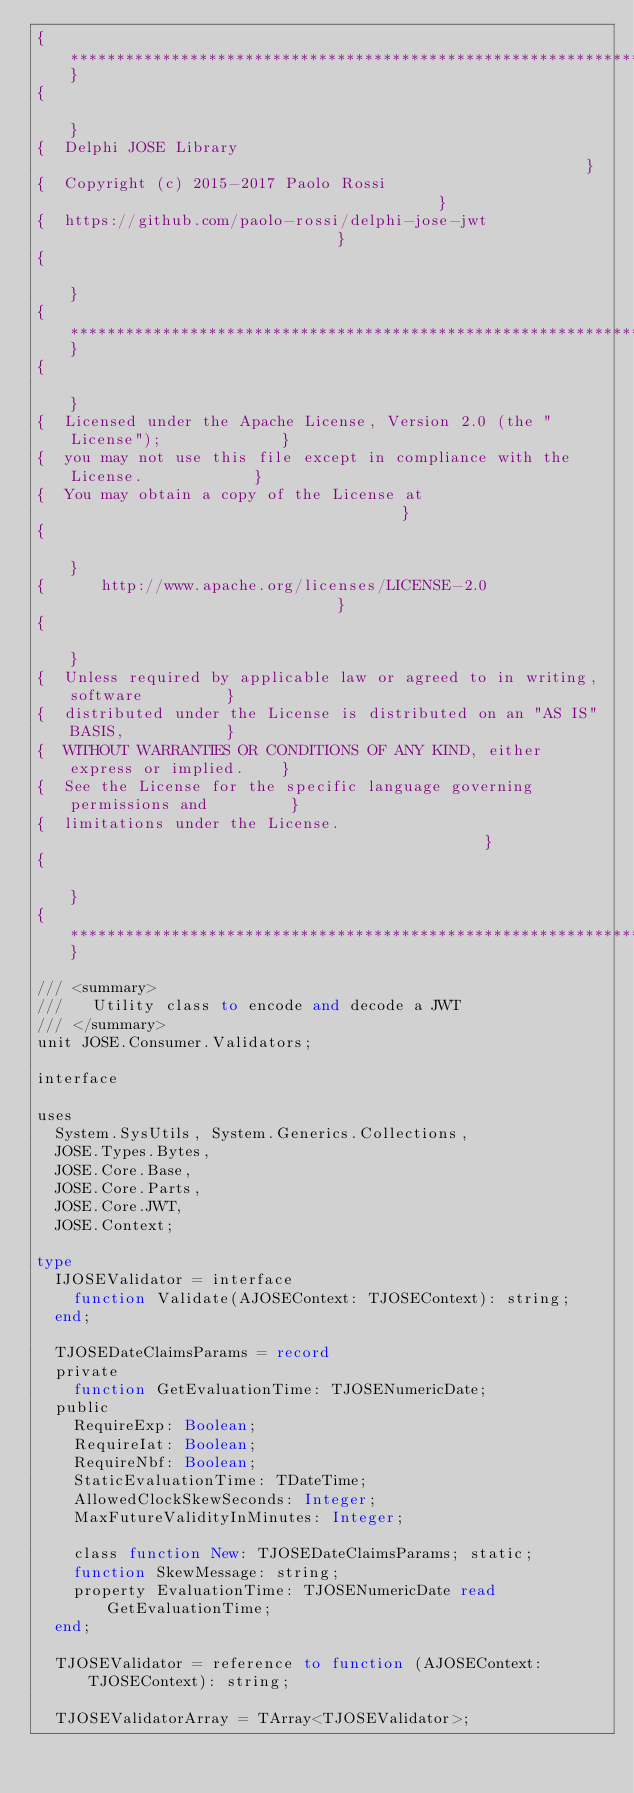<code> <loc_0><loc_0><loc_500><loc_500><_Pascal_>{******************************************************************************}
{                                                                              }
{  Delphi JOSE Library                                                         }
{  Copyright (c) 2015-2017 Paolo Rossi                                         }
{  https://github.com/paolo-rossi/delphi-jose-jwt                              }
{                                                                              }
{******************************************************************************}
{                                                                              }
{  Licensed under the Apache License, Version 2.0 (the "License");             }
{  you may not use this file except in compliance with the License.            }
{  You may obtain a copy of the License at                                     }
{                                                                              }
{      http://www.apache.org/licenses/LICENSE-2.0                              }
{                                                                              }
{  Unless required by applicable law or agreed to in writing, software         }
{  distributed under the License is distributed on an "AS IS" BASIS,           }
{  WITHOUT WARRANTIES OR CONDITIONS OF ANY KIND, either express or implied.    }
{  See the License for the specific language governing permissions and         }
{  limitations under the License.                                              }
{                                                                              }
{******************************************************************************}

/// <summary>
///   Utility class to encode and decode a JWT
/// </summary>
unit JOSE.Consumer.Validators;

interface

uses
  System.SysUtils, System.Generics.Collections,
  JOSE.Types.Bytes,
  JOSE.Core.Base,
  JOSE.Core.Parts,
  JOSE.Core.JWT,
  JOSE.Context;

type
  IJOSEValidator = interface
    function Validate(AJOSEContext: TJOSEContext): string;
  end;

  TJOSEDateClaimsParams = record
  private
    function GetEvaluationTime: TJOSENumericDate;
  public
    RequireExp: Boolean;
    RequireIat: Boolean;
    RequireNbf: Boolean;
    StaticEvaluationTime: TDateTime;
    AllowedClockSkewSeconds: Integer;
    MaxFutureValidityInMinutes: Integer;

    class function New: TJOSEDateClaimsParams; static;
    function SkewMessage: string;
    property EvaluationTime: TJOSENumericDate read GetEvaluationTime;
  end;

  TJOSEValidator = reference to function (AJOSEContext: TJOSEContext): string;

  TJOSEValidatorArray = TArray<TJOSEValidator>;</code> 